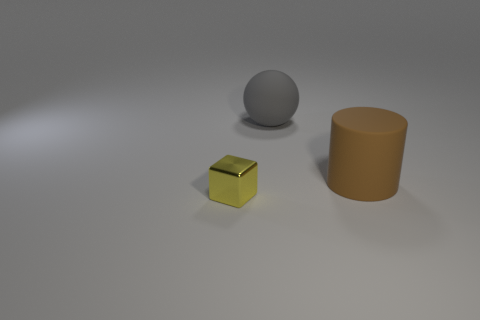The sphere that is made of the same material as the big brown object is what size?
Offer a very short reply. Large. How big is the brown cylinder?
Offer a very short reply. Large. The big gray object has what shape?
Make the answer very short. Sphere. There is a rubber object that is in front of the gray thing; does it have the same color as the block?
Offer a very short reply. No. Are there any other things that have the same material as the cylinder?
Provide a short and direct response. Yes. Is there a large rubber object that is to the right of the rubber thing in front of the large matte object that is behind the matte cylinder?
Make the answer very short. No. What material is the large thing that is in front of the matte ball?
Offer a terse response. Rubber. How many large things are either brown rubber cylinders or red rubber balls?
Make the answer very short. 1. Does the object behind the brown thing have the same size as the tiny object?
Give a very brief answer. No. What is the material of the large brown cylinder?
Your answer should be compact. Rubber. 